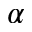<formula> <loc_0><loc_0><loc_500><loc_500>\alpha</formula> 